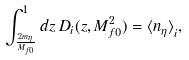<formula> <loc_0><loc_0><loc_500><loc_500>\int _ { { \frac { 2 m _ { \eta } } { M _ { f 0 } } } } ^ { 1 } d z \, D _ { i } ( z , M _ { f 0 } ^ { 2 } ) = { \langle n _ { \eta } \rangle } _ { i } ,</formula> 